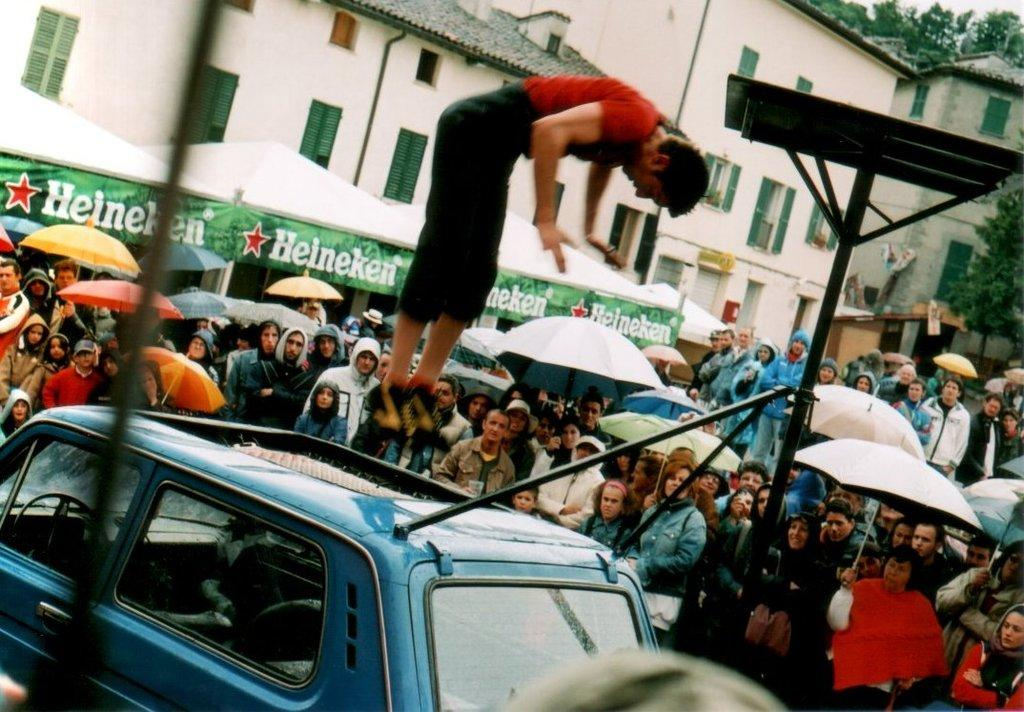<image>
Present a compact description of the photo's key features. Person flipping on a car in front of a sign that says "Heineken". 